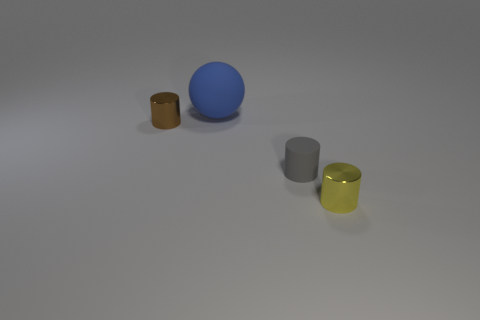Are there any other things that have the same size as the brown cylinder?
Keep it short and to the point. Yes. Are there fewer brown cylinders that are behind the big ball than large rubber objects in front of the small brown metallic cylinder?
Keep it short and to the point. No. How many other things are the same shape as the big rubber thing?
Give a very brief answer. 0. How big is the metal thing that is behind the small shiny object in front of the tiny cylinder behind the gray cylinder?
Keep it short and to the point. Small. What number of blue objects are big things or metal objects?
Your answer should be very brief. 1. There is a metallic thing that is in front of the metal object that is on the left side of the blue thing; what shape is it?
Offer a terse response. Cylinder. Is the size of the metallic cylinder that is on the right side of the big matte thing the same as the rubber thing that is in front of the big matte ball?
Make the answer very short. Yes. Are there any large blue things that have the same material as the yellow thing?
Make the answer very short. No. Are there any gray cylinders that are left of the tiny shiny thing that is in front of the cylinder on the left side of the large blue matte sphere?
Your response must be concise. Yes. Are there any yellow cylinders behind the gray rubber cylinder?
Keep it short and to the point. No. 